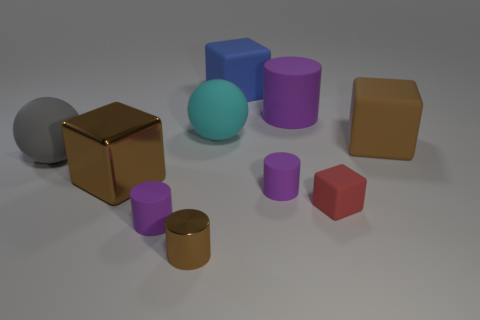How many tiny cubes are behind the large purple cylinder that is right of the brown shiny cylinder?
Your response must be concise. 0. Is the block that is behind the big purple thing made of the same material as the large brown thing that is to the left of the big blue matte thing?
Ensure brevity in your answer.  No. There is a tiny cylinder that is the same color as the metal cube; what material is it?
Your answer should be very brief. Metal. What number of other big brown shiny objects are the same shape as the big shiny thing?
Provide a succinct answer. 0. Is the big purple thing made of the same material as the big brown block in front of the gray matte sphere?
Give a very brief answer. No. There is a cyan object that is the same size as the gray object; what is its material?
Give a very brief answer. Rubber. Are there any red matte blocks that have the same size as the blue matte cube?
Offer a very short reply. No. There is a red object that is the same size as the brown metal cylinder; what is its shape?
Your answer should be very brief. Cube. How many other objects are the same color as the large metallic cube?
Provide a short and direct response. 2. There is a rubber object that is to the left of the blue matte object and behind the big brown rubber object; what shape is it?
Offer a terse response. Sphere. 